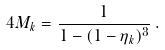<formula> <loc_0><loc_0><loc_500><loc_500>4 M _ { k } = \frac { 1 } { 1 - ( 1 - \eta _ { k } ) ^ { 3 } } \, .</formula> 